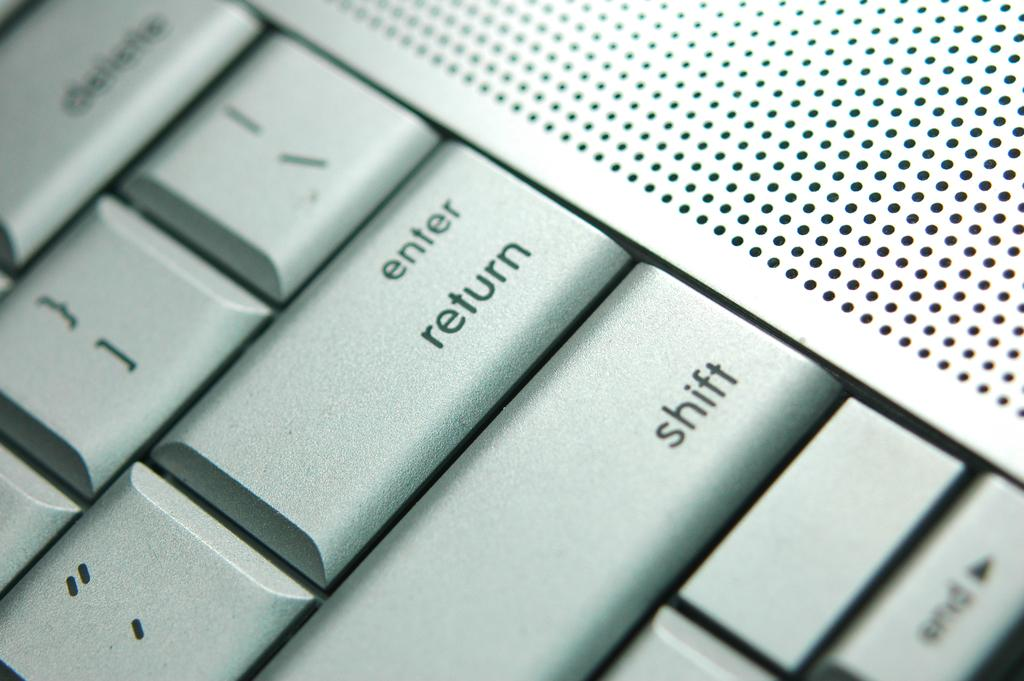<image>
Give a short and clear explanation of the subsequent image. A close up of a computer keyboard showing the enter and return key as well as the shift button. 